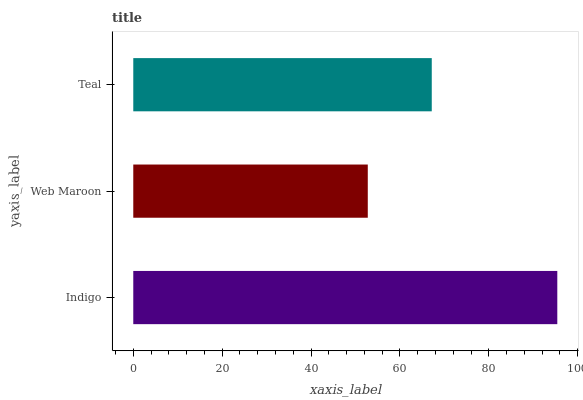Is Web Maroon the minimum?
Answer yes or no. Yes. Is Indigo the maximum?
Answer yes or no. Yes. Is Teal the minimum?
Answer yes or no. No. Is Teal the maximum?
Answer yes or no. No. Is Teal greater than Web Maroon?
Answer yes or no. Yes. Is Web Maroon less than Teal?
Answer yes or no. Yes. Is Web Maroon greater than Teal?
Answer yes or no. No. Is Teal less than Web Maroon?
Answer yes or no. No. Is Teal the high median?
Answer yes or no. Yes. Is Teal the low median?
Answer yes or no. Yes. Is Web Maroon the high median?
Answer yes or no. No. Is Web Maroon the low median?
Answer yes or no. No. 